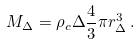<formula> <loc_0><loc_0><loc_500><loc_500>M _ { \Delta } = \rho _ { c } \Delta \frac { 4 } { 3 } \pi r _ { \Delta } ^ { 3 } \, .</formula> 